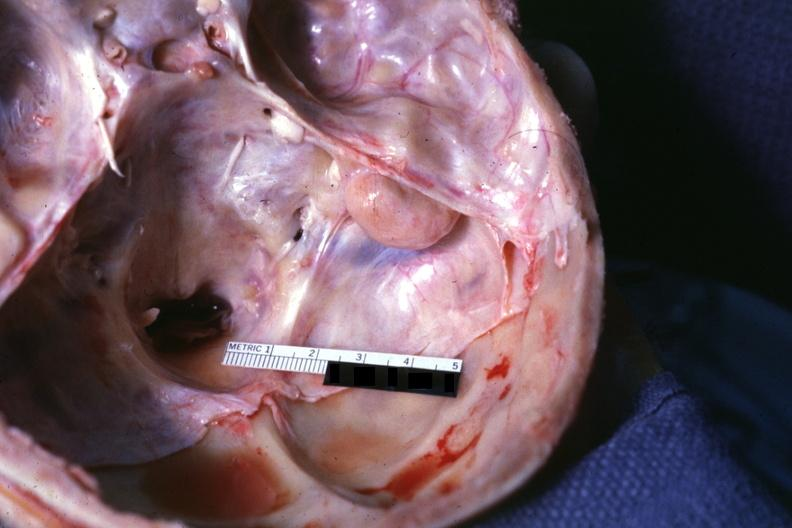s odontoid process subluxation with narrowing of foramen magnum removed?
Answer the question using a single word or phrase. No 